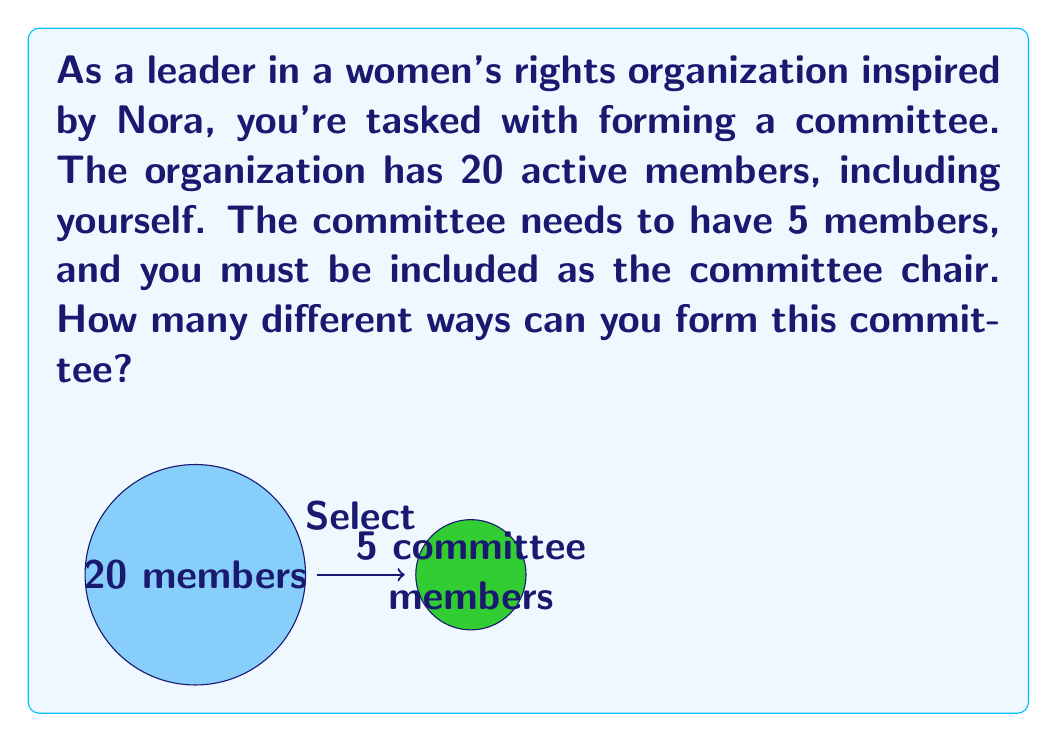Solve this math problem. Let's approach this step-by-step:

1) You are automatically included in the committee as the chair, so we only need to choose 4 more members from the remaining 19 people.

2) This is a combination problem. We're selecting 4 people from a group of 19, where the order doesn't matter.

3) The formula for combinations is:

   $$C(n,r) = \frac{n!}{r!(n-r)!}$$

   Where $n$ is the total number of items to choose from, and $r$ is the number of items being chosen.

4) In this case, $n = 19$ (remaining members) and $r = 4$ (additional committee members needed).

5) Plugging into the formula:

   $$C(19,4) = \frac{19!}{4!(19-4)!} = \frac{19!}{4!15!}$$

6) Calculating this:
   
   $$\frac{19 * 18 * 17 * 16 * 15!}{(4 * 3 * 2 * 1) * 15!}$$

7) The 15! cancels out in the numerator and denominator:

   $$\frac{19 * 18 * 17 * 16}{4 * 3 * 2 * 1} = \frac{92,416}{24} = 3,876$$

Therefore, there are 3,876 different ways to form the committee.
Answer: 3,876 